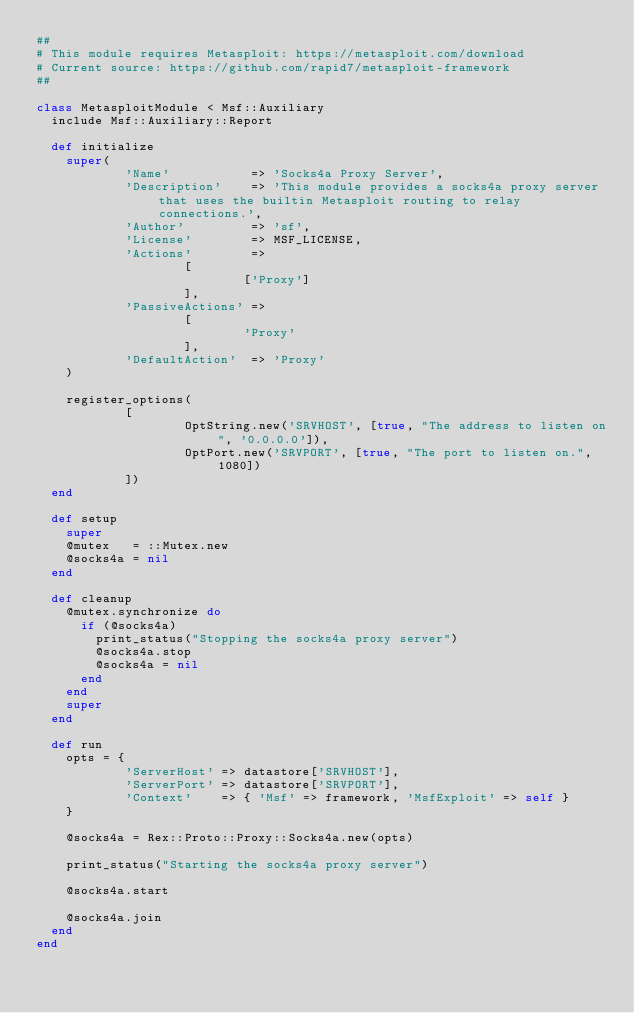Convert code to text. <code><loc_0><loc_0><loc_500><loc_500><_Ruby_>##
# This module requires Metasploit: https://metasploit.com/download
# Current source: https://github.com/rapid7/metasploit-framework
##

class MetasploitModule < Msf::Auxiliary
  include Msf::Auxiliary::Report

  def initialize
    super(
            'Name'           => 'Socks4a Proxy Server',
            'Description'    => 'This module provides a socks4a proxy server that uses the builtin Metasploit routing to relay connections.',
            'Author'         => 'sf',
            'License'        => MSF_LICENSE,
            'Actions'        =>
                    [
                            ['Proxy']
                    ],
            'PassiveActions' =>
                    [
                            'Proxy'
                    ],
            'DefaultAction'  => 'Proxy'
    )

    register_options(
            [
                    OptString.new('SRVHOST', [true, "The address to listen on", '0.0.0.0']),
                    OptPort.new('SRVPORT', [true, "The port to listen on.", 1080])
            ])
  end

  def setup
    super
    @mutex   = ::Mutex.new
    @socks4a = nil
  end

  def cleanup
    @mutex.synchronize do
      if (@socks4a)
        print_status("Stopping the socks4a proxy server")
        @socks4a.stop
        @socks4a = nil
      end
    end
    super
  end

  def run
    opts = {
            'ServerHost' => datastore['SRVHOST'],
            'ServerPort' => datastore['SRVPORT'],
            'Context'    => { 'Msf' => framework, 'MsfExploit' => self }
    }

    @socks4a = Rex::Proto::Proxy::Socks4a.new(opts)

    print_status("Starting the socks4a proxy server")

    @socks4a.start

    @socks4a.join
  end
end
</code> 